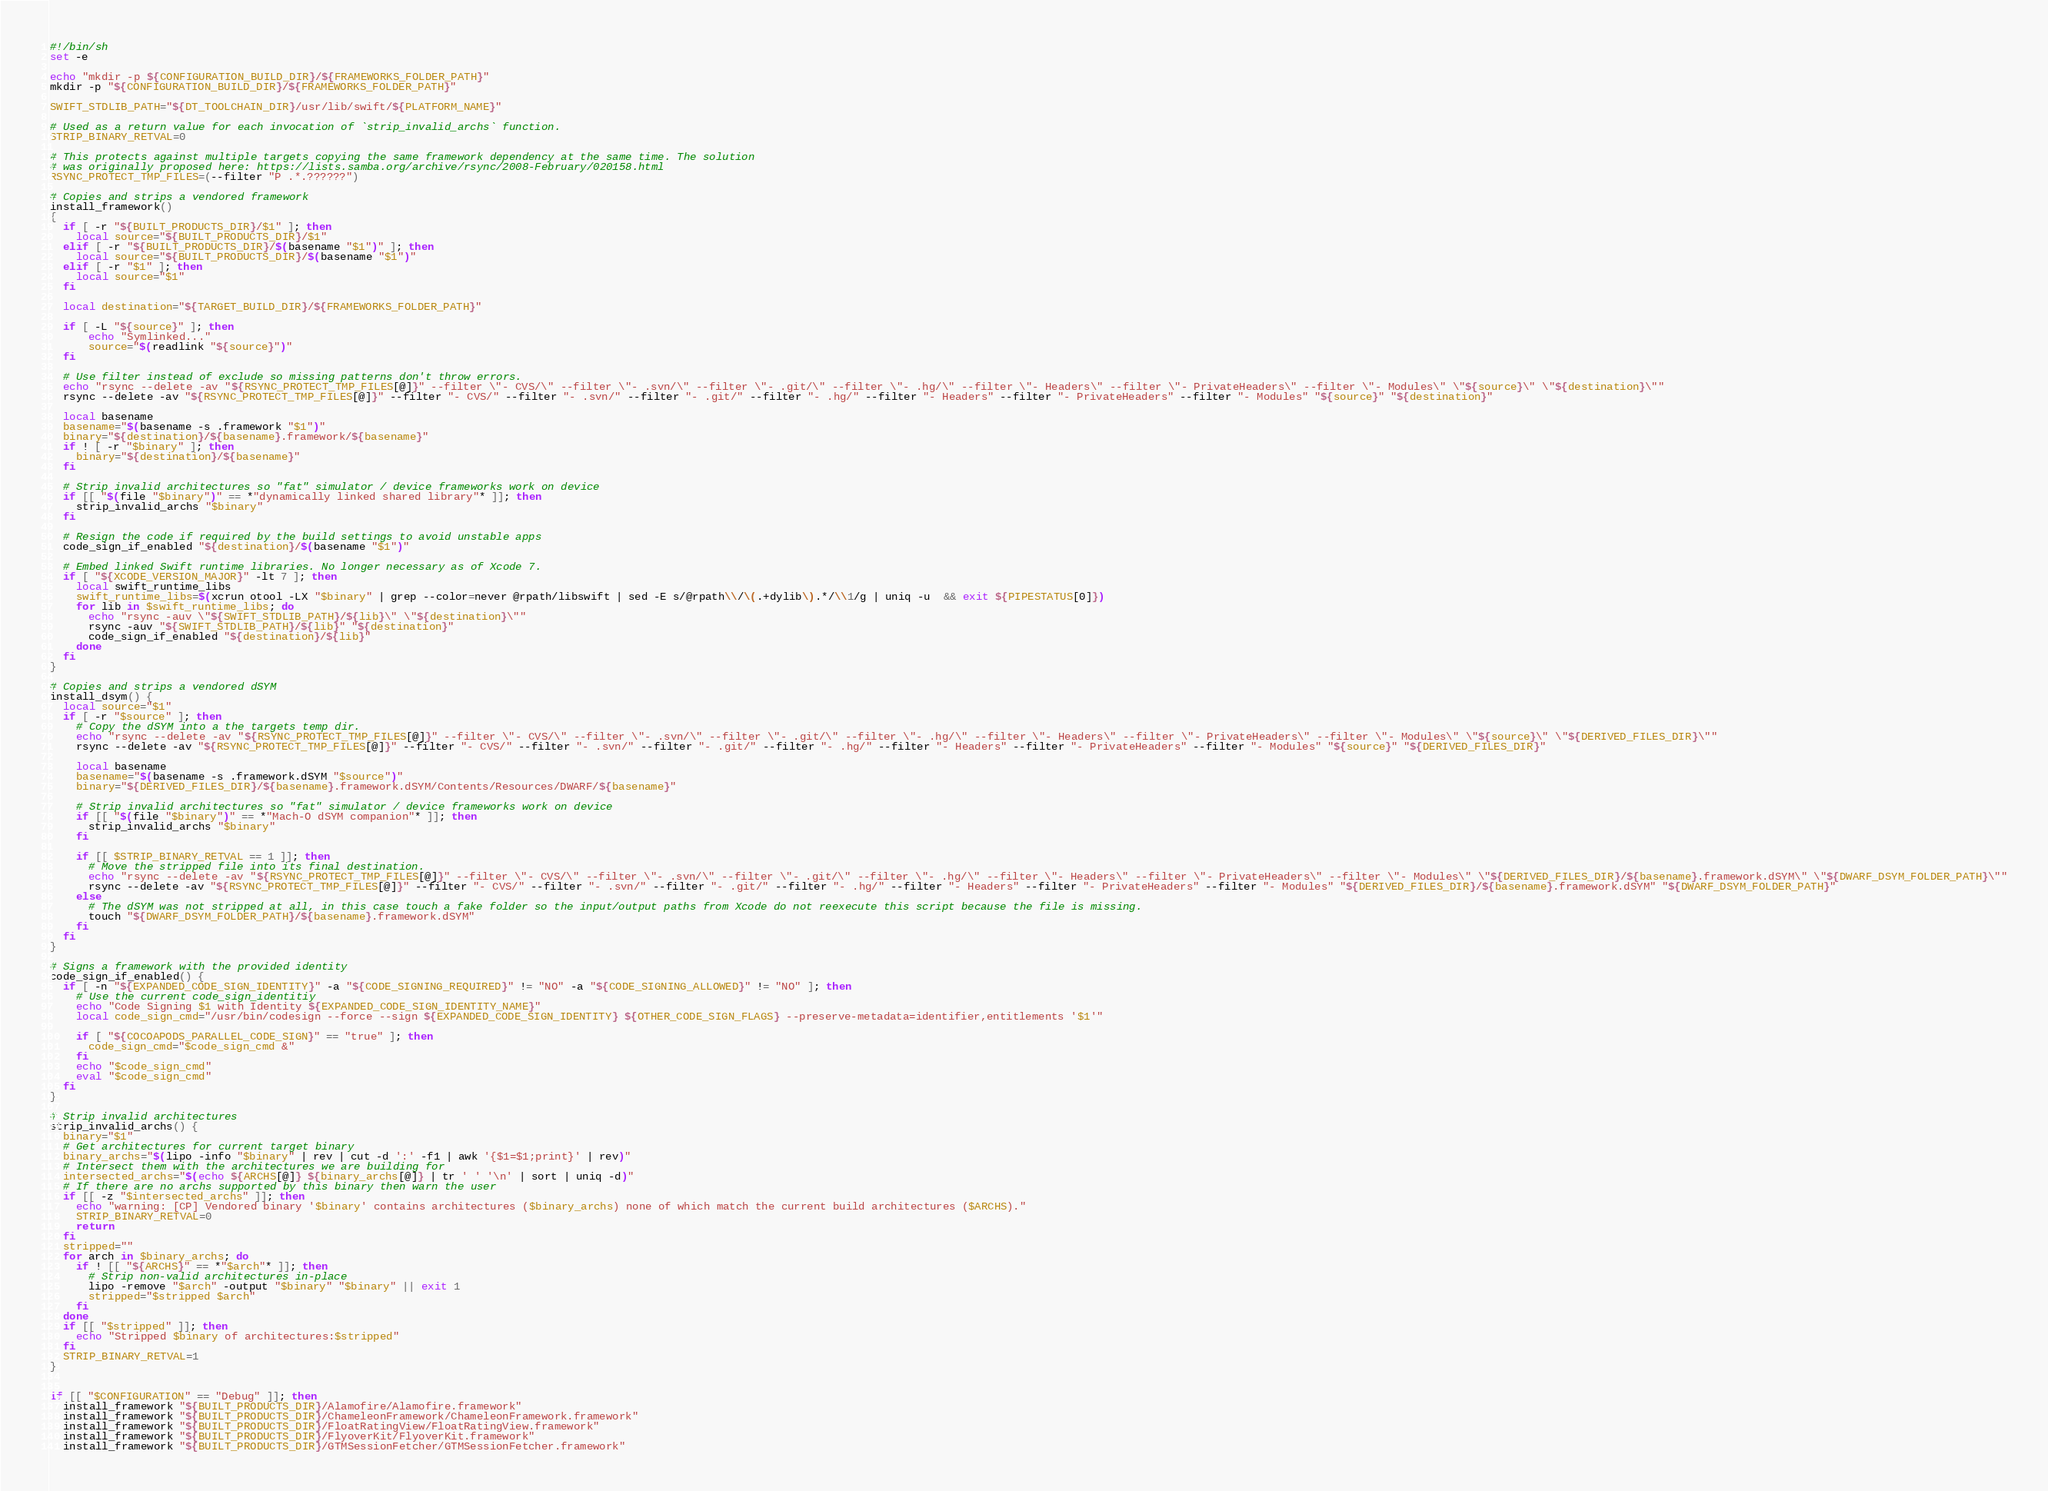Convert code to text. <code><loc_0><loc_0><loc_500><loc_500><_Bash_>#!/bin/sh
set -e

echo "mkdir -p ${CONFIGURATION_BUILD_DIR}/${FRAMEWORKS_FOLDER_PATH}"
mkdir -p "${CONFIGURATION_BUILD_DIR}/${FRAMEWORKS_FOLDER_PATH}"

SWIFT_STDLIB_PATH="${DT_TOOLCHAIN_DIR}/usr/lib/swift/${PLATFORM_NAME}"

# Used as a return value for each invocation of `strip_invalid_archs` function.
STRIP_BINARY_RETVAL=0

# This protects against multiple targets copying the same framework dependency at the same time. The solution
# was originally proposed here: https://lists.samba.org/archive/rsync/2008-February/020158.html
RSYNC_PROTECT_TMP_FILES=(--filter "P .*.??????")

# Copies and strips a vendored framework
install_framework()
{
  if [ -r "${BUILT_PRODUCTS_DIR}/$1" ]; then
    local source="${BUILT_PRODUCTS_DIR}/$1"
  elif [ -r "${BUILT_PRODUCTS_DIR}/$(basename "$1")" ]; then
    local source="${BUILT_PRODUCTS_DIR}/$(basename "$1")"
  elif [ -r "$1" ]; then
    local source="$1"
  fi

  local destination="${TARGET_BUILD_DIR}/${FRAMEWORKS_FOLDER_PATH}"

  if [ -L "${source}" ]; then
      echo "Symlinked..."
      source="$(readlink "${source}")"
  fi

  # Use filter instead of exclude so missing patterns don't throw errors.
  echo "rsync --delete -av "${RSYNC_PROTECT_TMP_FILES[@]}" --filter \"- CVS/\" --filter \"- .svn/\" --filter \"- .git/\" --filter \"- .hg/\" --filter \"- Headers\" --filter \"- PrivateHeaders\" --filter \"- Modules\" \"${source}\" \"${destination}\""
  rsync --delete -av "${RSYNC_PROTECT_TMP_FILES[@]}" --filter "- CVS/" --filter "- .svn/" --filter "- .git/" --filter "- .hg/" --filter "- Headers" --filter "- PrivateHeaders" --filter "- Modules" "${source}" "${destination}"

  local basename
  basename="$(basename -s .framework "$1")"
  binary="${destination}/${basename}.framework/${basename}"
  if ! [ -r "$binary" ]; then
    binary="${destination}/${basename}"
  fi

  # Strip invalid architectures so "fat" simulator / device frameworks work on device
  if [[ "$(file "$binary")" == *"dynamically linked shared library"* ]]; then
    strip_invalid_archs "$binary"
  fi

  # Resign the code if required by the build settings to avoid unstable apps
  code_sign_if_enabled "${destination}/$(basename "$1")"

  # Embed linked Swift runtime libraries. No longer necessary as of Xcode 7.
  if [ "${XCODE_VERSION_MAJOR}" -lt 7 ]; then
    local swift_runtime_libs
    swift_runtime_libs=$(xcrun otool -LX "$binary" | grep --color=never @rpath/libswift | sed -E s/@rpath\\/\(.+dylib\).*/\\1/g | uniq -u  && exit ${PIPESTATUS[0]})
    for lib in $swift_runtime_libs; do
      echo "rsync -auv \"${SWIFT_STDLIB_PATH}/${lib}\" \"${destination}\""
      rsync -auv "${SWIFT_STDLIB_PATH}/${lib}" "${destination}"
      code_sign_if_enabled "${destination}/${lib}"
    done
  fi
}

# Copies and strips a vendored dSYM
install_dsym() {
  local source="$1"
  if [ -r "$source" ]; then
    # Copy the dSYM into a the targets temp dir.
    echo "rsync --delete -av "${RSYNC_PROTECT_TMP_FILES[@]}" --filter \"- CVS/\" --filter \"- .svn/\" --filter \"- .git/\" --filter \"- .hg/\" --filter \"- Headers\" --filter \"- PrivateHeaders\" --filter \"- Modules\" \"${source}\" \"${DERIVED_FILES_DIR}\""
    rsync --delete -av "${RSYNC_PROTECT_TMP_FILES[@]}" --filter "- CVS/" --filter "- .svn/" --filter "- .git/" --filter "- .hg/" --filter "- Headers" --filter "- PrivateHeaders" --filter "- Modules" "${source}" "${DERIVED_FILES_DIR}"

    local basename
    basename="$(basename -s .framework.dSYM "$source")"
    binary="${DERIVED_FILES_DIR}/${basename}.framework.dSYM/Contents/Resources/DWARF/${basename}"

    # Strip invalid architectures so "fat" simulator / device frameworks work on device
    if [[ "$(file "$binary")" == *"Mach-O dSYM companion"* ]]; then
      strip_invalid_archs "$binary"
    fi

    if [[ $STRIP_BINARY_RETVAL == 1 ]]; then
      # Move the stripped file into its final destination.
      echo "rsync --delete -av "${RSYNC_PROTECT_TMP_FILES[@]}" --filter \"- CVS/\" --filter \"- .svn/\" --filter \"- .git/\" --filter \"- .hg/\" --filter \"- Headers\" --filter \"- PrivateHeaders\" --filter \"- Modules\" \"${DERIVED_FILES_DIR}/${basename}.framework.dSYM\" \"${DWARF_DSYM_FOLDER_PATH}\""
      rsync --delete -av "${RSYNC_PROTECT_TMP_FILES[@]}" --filter "- CVS/" --filter "- .svn/" --filter "- .git/" --filter "- .hg/" --filter "- Headers" --filter "- PrivateHeaders" --filter "- Modules" "${DERIVED_FILES_DIR}/${basename}.framework.dSYM" "${DWARF_DSYM_FOLDER_PATH}"
    else
      # The dSYM was not stripped at all, in this case touch a fake folder so the input/output paths from Xcode do not reexecute this script because the file is missing.
      touch "${DWARF_DSYM_FOLDER_PATH}/${basename}.framework.dSYM"
    fi
  fi
}

# Signs a framework with the provided identity
code_sign_if_enabled() {
  if [ -n "${EXPANDED_CODE_SIGN_IDENTITY}" -a "${CODE_SIGNING_REQUIRED}" != "NO" -a "${CODE_SIGNING_ALLOWED}" != "NO" ]; then
    # Use the current code_sign_identitiy
    echo "Code Signing $1 with Identity ${EXPANDED_CODE_SIGN_IDENTITY_NAME}"
    local code_sign_cmd="/usr/bin/codesign --force --sign ${EXPANDED_CODE_SIGN_IDENTITY} ${OTHER_CODE_SIGN_FLAGS} --preserve-metadata=identifier,entitlements '$1'"

    if [ "${COCOAPODS_PARALLEL_CODE_SIGN}" == "true" ]; then
      code_sign_cmd="$code_sign_cmd &"
    fi
    echo "$code_sign_cmd"
    eval "$code_sign_cmd"
  fi
}

# Strip invalid architectures
strip_invalid_archs() {
  binary="$1"
  # Get architectures for current target binary
  binary_archs="$(lipo -info "$binary" | rev | cut -d ':' -f1 | awk '{$1=$1;print}' | rev)"
  # Intersect them with the architectures we are building for
  intersected_archs="$(echo ${ARCHS[@]} ${binary_archs[@]} | tr ' ' '\n' | sort | uniq -d)"
  # If there are no archs supported by this binary then warn the user
  if [[ -z "$intersected_archs" ]]; then
    echo "warning: [CP] Vendored binary '$binary' contains architectures ($binary_archs) none of which match the current build architectures ($ARCHS)."
    STRIP_BINARY_RETVAL=0
    return
  fi
  stripped=""
  for arch in $binary_archs; do
    if ! [[ "${ARCHS}" == *"$arch"* ]]; then
      # Strip non-valid architectures in-place
      lipo -remove "$arch" -output "$binary" "$binary" || exit 1
      stripped="$stripped $arch"
    fi
  done
  if [[ "$stripped" ]]; then
    echo "Stripped $binary of architectures:$stripped"
  fi
  STRIP_BINARY_RETVAL=1
}


if [[ "$CONFIGURATION" == "Debug" ]]; then
  install_framework "${BUILT_PRODUCTS_DIR}/Alamofire/Alamofire.framework"
  install_framework "${BUILT_PRODUCTS_DIR}/ChameleonFramework/ChameleonFramework.framework"
  install_framework "${BUILT_PRODUCTS_DIR}/FloatRatingView/FloatRatingView.framework"
  install_framework "${BUILT_PRODUCTS_DIR}/FlyoverKit/FlyoverKit.framework"
  install_framework "${BUILT_PRODUCTS_DIR}/GTMSessionFetcher/GTMSessionFetcher.framework"</code> 